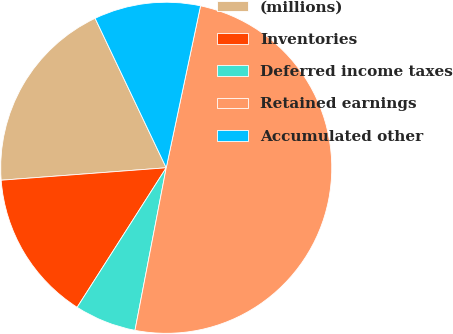Convert chart. <chart><loc_0><loc_0><loc_500><loc_500><pie_chart><fcel>(millions)<fcel>Inventories<fcel>Deferred income taxes<fcel>Retained earnings<fcel>Accumulated other<nl><fcel>19.13%<fcel>14.76%<fcel>6.02%<fcel>49.7%<fcel>10.39%<nl></chart> 